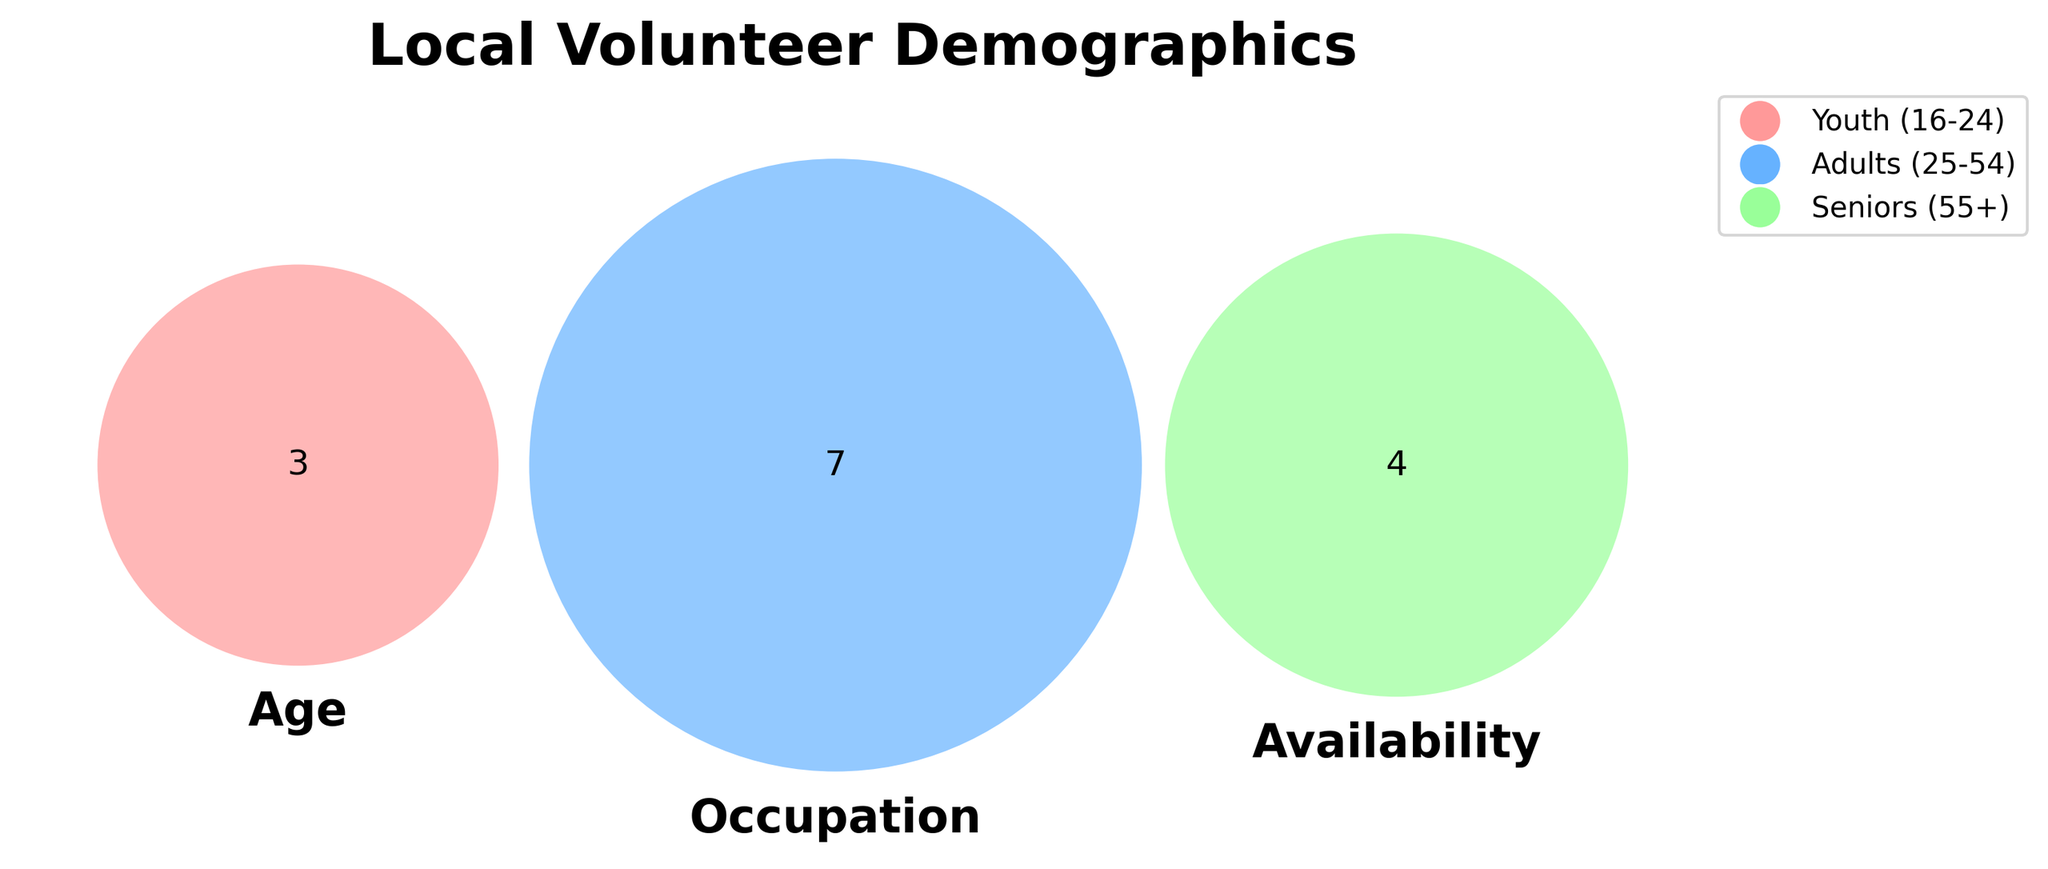What does the title of the Venn diagram indicate? The title of the Venn diagram should clearly indicate the demographics represented in the data. By examining the top of the figure, one can read the title and interpret it.
Answer: Local Volunteer Demographics What are the colors used to represent the different sets in the Venn diagram? The colors used in the Venn diagram are visible in the figure, and they correspond to different sets. One can identify these colors by looking at the Venn diagram's sections and the provided legend.
Answer: Red, Blue, Green Which age group has flexible availability? By looking at the intersection of the respective sections in the Venn diagram and the legend, one can identify which age group falls under 'Flexible' availability.
Answer: Youth, Adults Which occupations are included under 'Weekdays' availability? The occupations under 'Weekdays' availability are specified in one section of the Venn diagram. To find them, one should look at the areas overlapping with 'Weekdays'.
Answer: Retirees, Unemployed, Homemakers What occupation is common across all age groups? To find an occupation common across all age groups, one should look for the occupation that intersects with all other circles in the Venn diagram.
Answer: None Which group(s) overlap between 'Adults' and 'Self-employed'? The overlapping area between 'Adults' age group and 'Self-employed' can be found by looking at the intersection of the respective sections in the Venn diagram.
Answer: Adults How many age groups intersect with 'Professionals' occupation? By analyzing the Venn diagram's regions, one can count the number of age groups that intersect with the 'Professionals' occupation area.
Answer: One Is there any occupation that is exclusive to a specific age group? If yes, which one and for which age group? One can identify if there are exclusive overlaps by looking for sections that do not intersect with any other age group in the Venn diagram.
Answer: Homemakers for Seniors What occupation is available on weekends? By focusing on the segment associated with 'Weekends' in the Venn diagram, you can identify the related occupation.
Answer: Students Are there any overlapping occupations between 'Part-time workers' and 'Flexible' availability? Observing the intersection of 'Part-time workers' and 'Flexible' sections in the Venn diagram will provide the answer.
Answer: Yes, Youth 